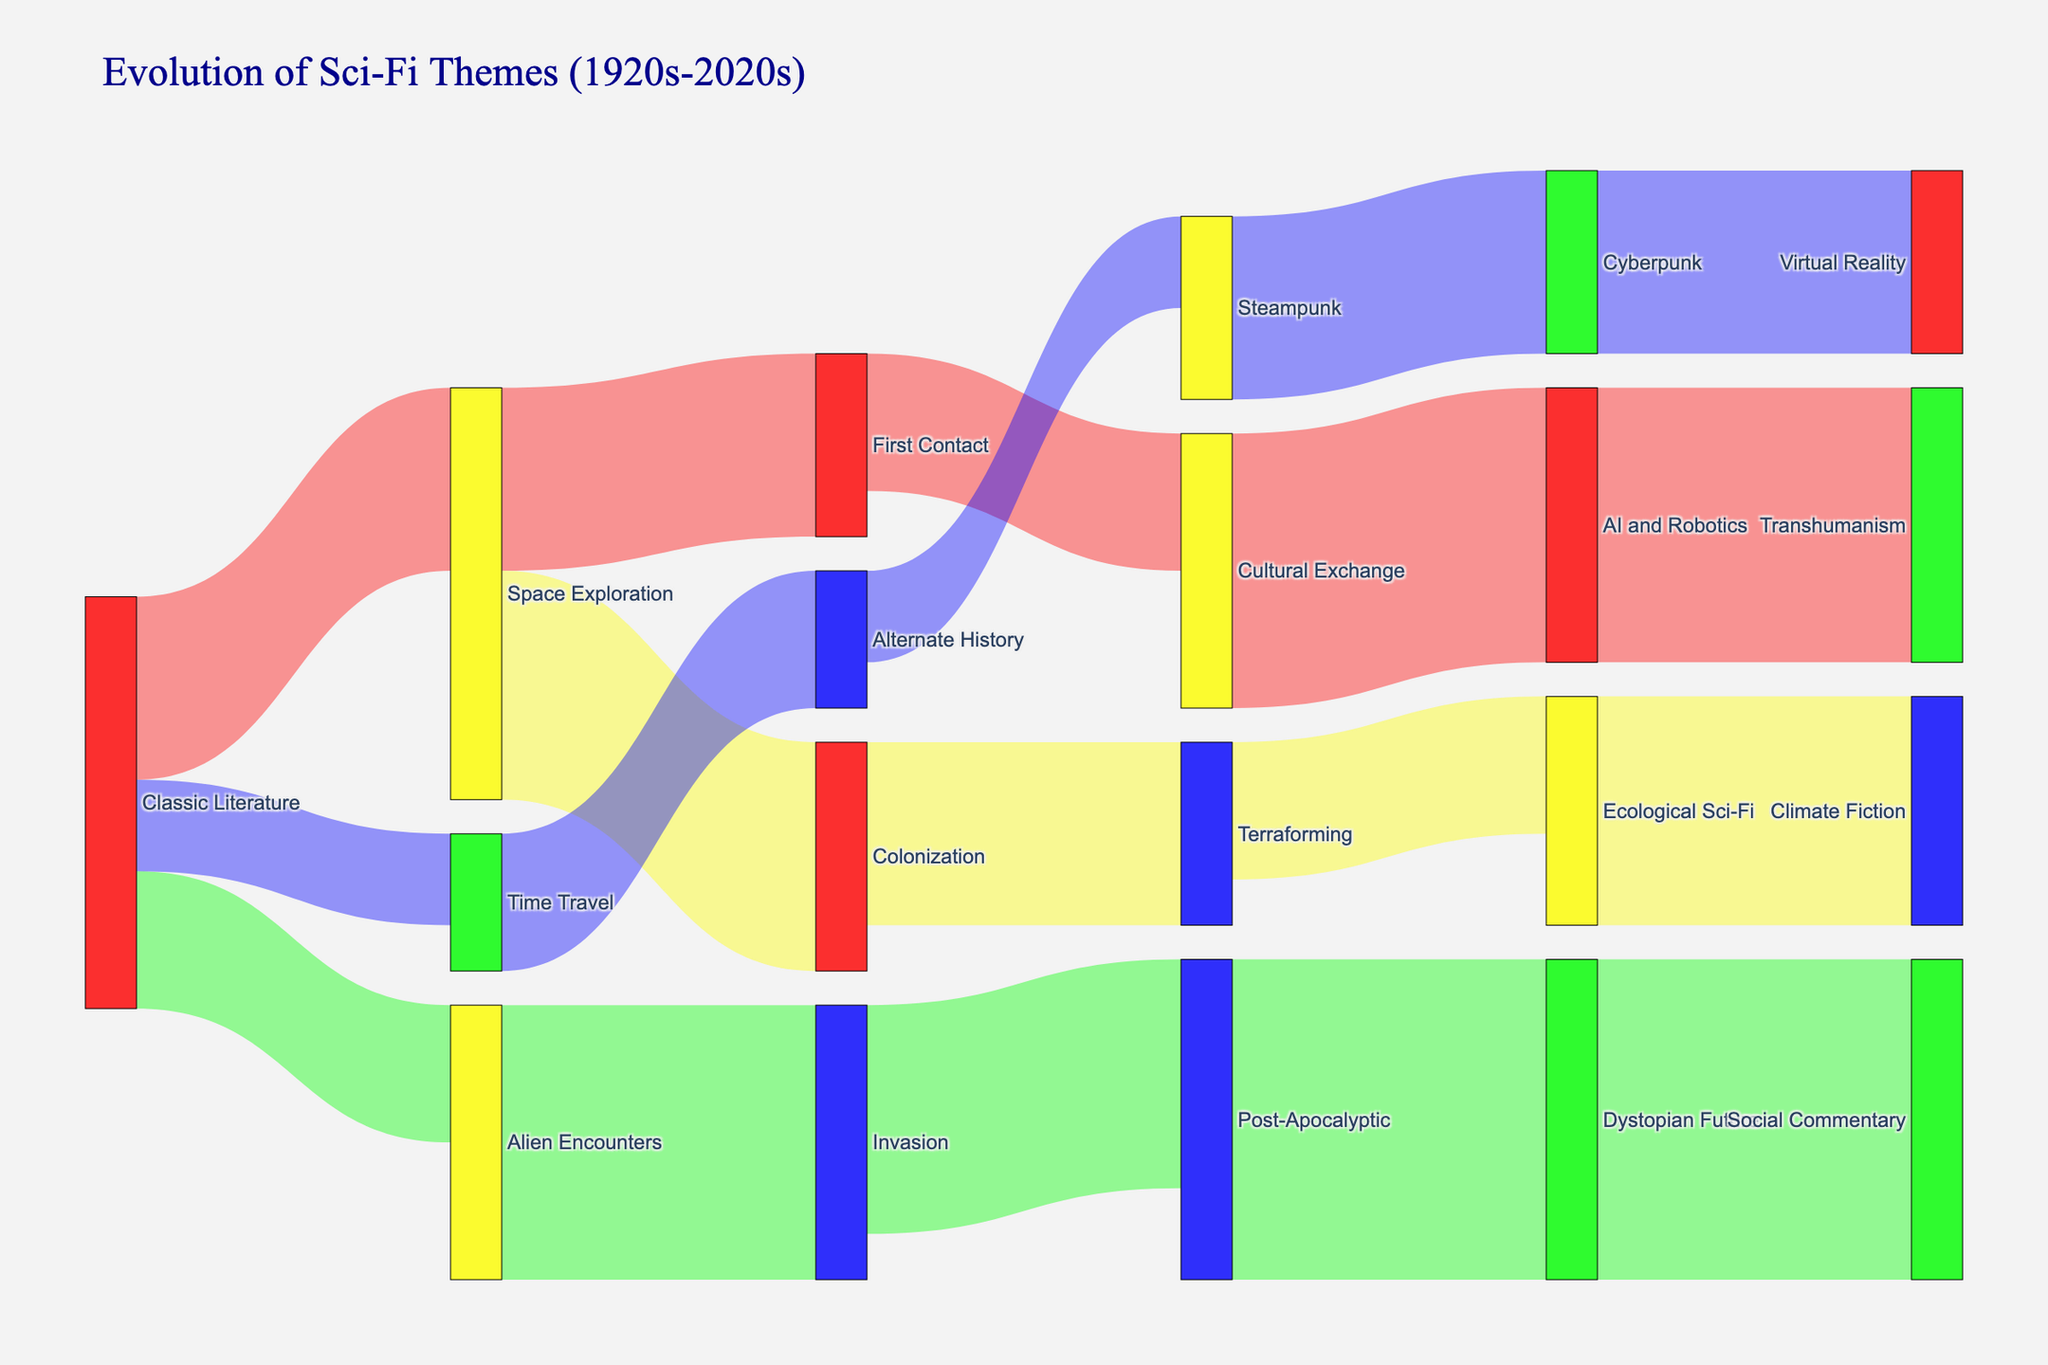Which theme dominates the 2010s? The Dystopian Future theme is the most popular in the 2010s, as indicated by the largest flow and popularity value of 35.
Answer: Dystopian Future From which source does the Terraforming theme evolve? The TF theme evolves from the SP Science Exploration theme in the 1980s, shown by a connecting flow from SE to TF.
Answer: Space Exploration What are the themes that directly evolve from Dystopian Future? DF theme evolves into the Social Commentary theme in the 2020s, as shown by the connecting flow.
Answer: Social Commentary Which decade has the most popular theme in this diagram? The 2010s host the most popular Dystopian Future theme with a popularity value of 35.
Answer: 2010s How many themes evolve from the Space Exploration theme in the 1950s? Two themes, Colonization and First Contact, evolve from the SE theme in the 1950s, which is shown by two connecting flows.
Answer: 2 What is the popularity difference between the Terraforming theme and the AI & Robotics theme in the 2010s? Terraforming has a popularity value of 15, and AI & Robotics has a value of 30. Therefore, the difference is 30 - 15 = 15.
Answer: 15 Compare the popularity of Post-Apocalyptic and Steampunk themes in the 1980s. Which one is more popular? Post-Apocalyptic has a popularity value of 25, while Steampunk has a value of 10. Post-Apocalyptic is more popular.
Answer: Post-Apocalyptic What is the total popularity of themes originating from Alien Encounters in the 1950s? The themes originating from AE in the 1950s are Invasion with a popularity of 30. The total is 30.
Answer: 30 Between Virtual Reality and Social Commentary themes in the 2020s, which one has lesser popularity, and by how much? VR has a popularity of 20, and SC has 35. Thus, VR is 35 - 20 = 15 less popular than SC.
Answer: Virtual Reality, 15 How many themes originate directly from Classic Literature in the 1920s? Three themes, Space Exploration, Alien Encounters, and Time Travel, originate directly from Classic Literature in the 1920s.
Answer: 3 